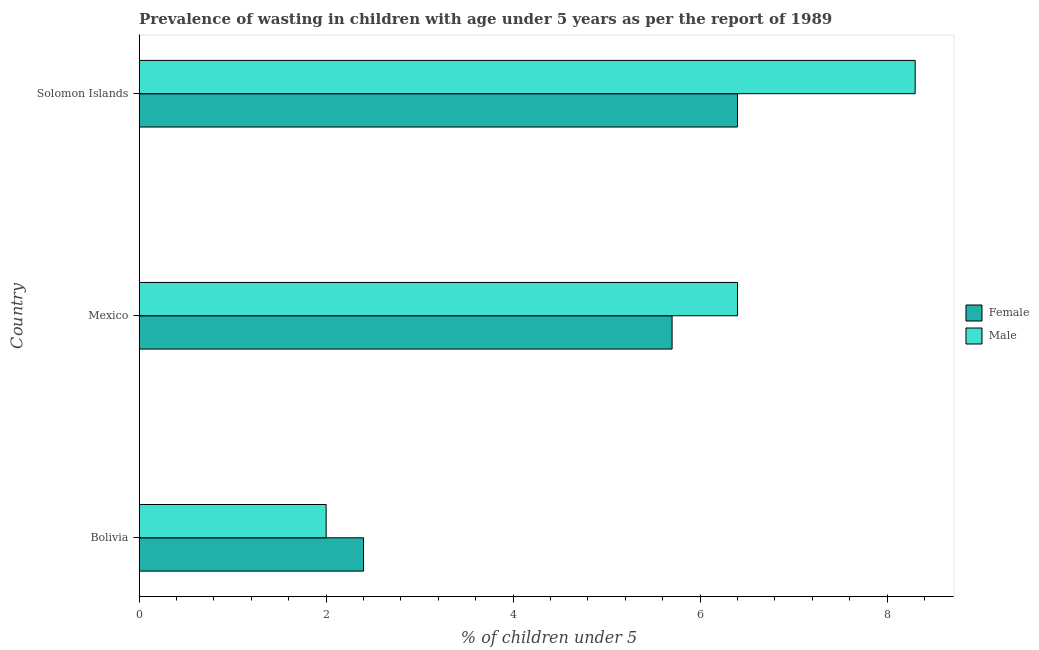Are the number of bars per tick equal to the number of legend labels?
Keep it short and to the point. Yes. How many bars are there on the 2nd tick from the bottom?
Give a very brief answer. 2. What is the label of the 2nd group of bars from the top?
Provide a succinct answer. Mexico. In how many cases, is the number of bars for a given country not equal to the number of legend labels?
Offer a very short reply. 0. What is the percentage of undernourished female children in Bolivia?
Your answer should be compact. 2.4. Across all countries, what is the maximum percentage of undernourished male children?
Your response must be concise. 8.3. Across all countries, what is the minimum percentage of undernourished female children?
Offer a terse response. 2.4. In which country was the percentage of undernourished male children maximum?
Give a very brief answer. Solomon Islands. What is the total percentage of undernourished male children in the graph?
Make the answer very short. 16.7. What is the average percentage of undernourished male children per country?
Give a very brief answer. 5.57. What is the difference between the percentage of undernourished male children and percentage of undernourished female children in Bolivia?
Your response must be concise. -0.4. What is the ratio of the percentage of undernourished male children in Mexico to that in Solomon Islands?
Offer a terse response. 0.77. Is the difference between the percentage of undernourished female children in Bolivia and Solomon Islands greater than the difference between the percentage of undernourished male children in Bolivia and Solomon Islands?
Ensure brevity in your answer.  Yes. What is the difference between the highest and the second highest percentage of undernourished male children?
Provide a succinct answer. 1.9. In how many countries, is the percentage of undernourished male children greater than the average percentage of undernourished male children taken over all countries?
Provide a short and direct response. 2. What does the 1st bar from the top in Solomon Islands represents?
Give a very brief answer. Male. How many bars are there?
Provide a succinct answer. 6. How many countries are there in the graph?
Your response must be concise. 3. Does the graph contain grids?
Keep it short and to the point. No. How many legend labels are there?
Your response must be concise. 2. What is the title of the graph?
Give a very brief answer. Prevalence of wasting in children with age under 5 years as per the report of 1989. What is the label or title of the X-axis?
Your response must be concise.  % of children under 5. What is the label or title of the Y-axis?
Your response must be concise. Country. What is the  % of children under 5 of Female in Bolivia?
Keep it short and to the point. 2.4. What is the  % of children under 5 of Male in Bolivia?
Ensure brevity in your answer.  2. What is the  % of children under 5 in Female in Mexico?
Your response must be concise. 5.7. What is the  % of children under 5 in Male in Mexico?
Offer a terse response. 6.4. What is the  % of children under 5 of Female in Solomon Islands?
Make the answer very short. 6.4. What is the  % of children under 5 of Male in Solomon Islands?
Provide a short and direct response. 8.3. Across all countries, what is the maximum  % of children under 5 of Female?
Your response must be concise. 6.4. Across all countries, what is the maximum  % of children under 5 of Male?
Provide a short and direct response. 8.3. Across all countries, what is the minimum  % of children under 5 of Female?
Offer a very short reply. 2.4. What is the total  % of children under 5 in Male in the graph?
Your response must be concise. 16.7. What is the difference between the  % of children under 5 of Female in Bolivia and that in Mexico?
Keep it short and to the point. -3.3. What is the difference between the  % of children under 5 in Male in Bolivia and that in Mexico?
Keep it short and to the point. -4.4. What is the difference between the  % of children under 5 of Female in Bolivia and that in Solomon Islands?
Your response must be concise. -4. What is the difference between the  % of children under 5 of Male in Bolivia and that in Solomon Islands?
Provide a succinct answer. -6.3. What is the difference between the  % of children under 5 of Female in Mexico and that in Solomon Islands?
Your response must be concise. -0.7. What is the difference between the  % of children under 5 in Female in Bolivia and the  % of children under 5 in Male in Solomon Islands?
Ensure brevity in your answer.  -5.9. What is the difference between the  % of children under 5 of Female in Mexico and the  % of children under 5 of Male in Solomon Islands?
Your answer should be very brief. -2.6. What is the average  % of children under 5 in Female per country?
Give a very brief answer. 4.83. What is the average  % of children under 5 of Male per country?
Ensure brevity in your answer.  5.57. What is the difference between the  % of children under 5 of Female and  % of children under 5 of Male in Mexico?
Ensure brevity in your answer.  -0.7. What is the ratio of the  % of children under 5 of Female in Bolivia to that in Mexico?
Provide a succinct answer. 0.42. What is the ratio of the  % of children under 5 in Male in Bolivia to that in Mexico?
Give a very brief answer. 0.31. What is the ratio of the  % of children under 5 of Female in Bolivia to that in Solomon Islands?
Offer a very short reply. 0.38. What is the ratio of the  % of children under 5 of Male in Bolivia to that in Solomon Islands?
Offer a terse response. 0.24. What is the ratio of the  % of children under 5 of Female in Mexico to that in Solomon Islands?
Make the answer very short. 0.89. What is the ratio of the  % of children under 5 of Male in Mexico to that in Solomon Islands?
Provide a succinct answer. 0.77. What is the difference between the highest and the second highest  % of children under 5 of Female?
Your answer should be very brief. 0.7. What is the difference between the highest and the second highest  % of children under 5 of Male?
Ensure brevity in your answer.  1.9. What is the difference between the highest and the lowest  % of children under 5 in Female?
Make the answer very short. 4. What is the difference between the highest and the lowest  % of children under 5 of Male?
Offer a terse response. 6.3. 